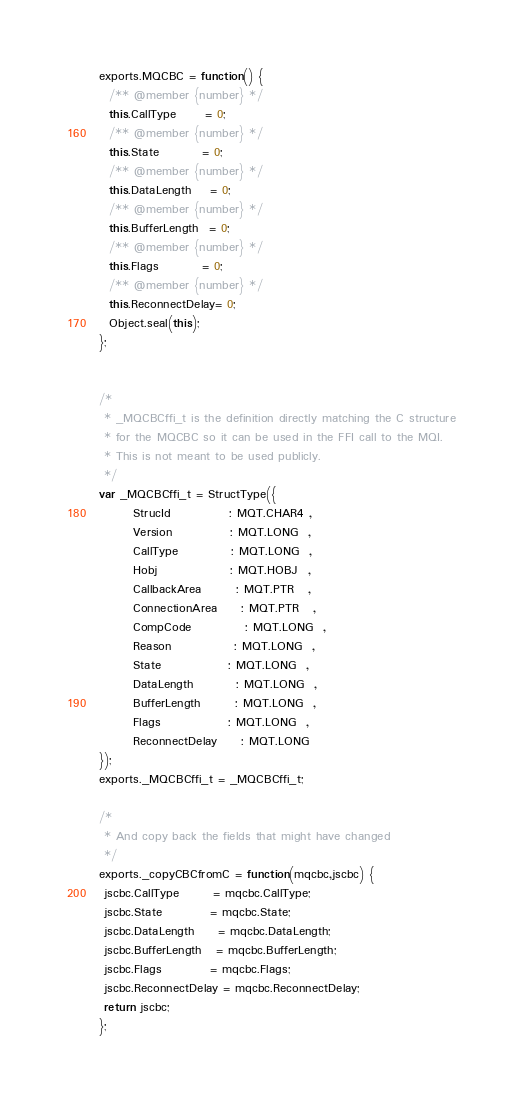Convert code to text. <code><loc_0><loc_0><loc_500><loc_500><_JavaScript_>exports.MQCBC = function() {
  /** @member {number} */
  this.CallType      = 0;
  /** @member {number} */
  this.State         = 0;
  /** @member {number} */
  this.DataLength    = 0;
  /** @member {number} */
  this.BufferLength  = 0;
  /** @member {number} */
  this.Flags         = 0;
  /** @member {number} */
  this.ReconnectDelay= 0;
  Object.seal(this);
};


/*
 * _MQCBCffi_t is the definition directly matching the C structure
 * for the MQCBC so it can be used in the FFI call to the MQI.
 * This is not meant to be used publicly.
 */
var _MQCBCffi_t = StructType({
       StrucId            : MQT.CHAR4 ,
       Version            : MQT.LONG  ,
       CallType           : MQT.LONG  ,
       Hobj               : MQT.HOBJ  ,
       CallbackArea       : MQT.PTR   ,
       ConnectionArea     : MQT.PTR   ,
       CompCode           : MQT.LONG  ,
       Reason             : MQT.LONG  ,
       State              : MQT.LONG  ,
       DataLength         : MQT.LONG  ,
       BufferLength       : MQT.LONG  ,
       Flags              : MQT.LONG  ,
       ReconnectDelay     : MQT.LONG
});
exports._MQCBCffi_t = _MQCBCffi_t;

/*
 * And copy back the fields that might have changed
 */
exports._copyCBCfromC = function(mqcbc,jscbc) {
 jscbc.CallType       = mqcbc.CallType;
 jscbc.State          = mqcbc.State;
 jscbc.DataLength     = mqcbc.DataLength;
 jscbc.BufferLength   = mqcbc.BufferLength;
 jscbc.Flags          = mqcbc.Flags;
 jscbc.ReconnectDelay = mqcbc.ReconnectDelay;
 return jscbc;
};
</code> 